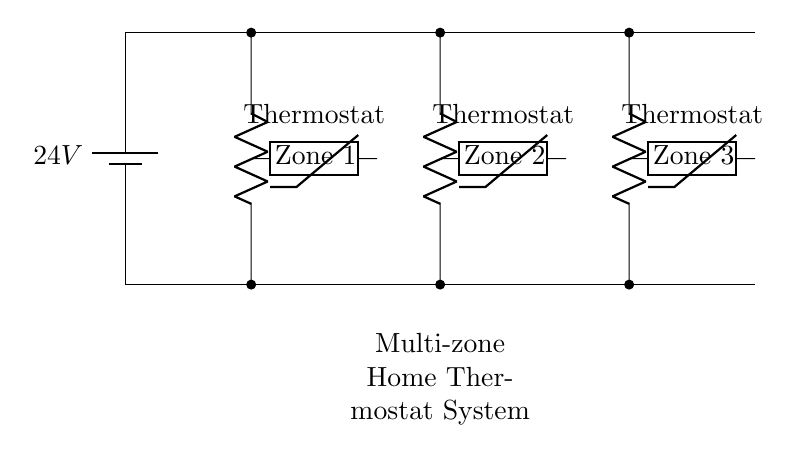What is the voltage of this circuit? The voltage is 24V, which is indicated on the battery symbol in the circuit diagram.
Answer: 24V What components are present in each zone? Each zone contains a resistor labeled as "Zone 1," "Zone 2," or "Zone 3," as well as a thermistor labeled "Thermostat."
Answer: Resistor and thermistor How many zones are independently controlled? There are three zones, as represented by the three distinct resistors in the circuit diagram.
Answer: 3 What is the configuration of the circuit? The circuit is a parallel configuration, as each zone's components are connected alongside each other between the same voltage source.
Answer: Parallel In which direction does current flow in this circuit? Current flows from the positive terminal of the battery through each zone and returns to the negative terminal, indicating a typical flow in a closed loop for each zone.
Answer: From positive to negative What type of controller is used for each zone? Each zone uses a thermistor as the control element to detect temperature and manage heating or cooling for that specific area.
Answer: Thermistor 